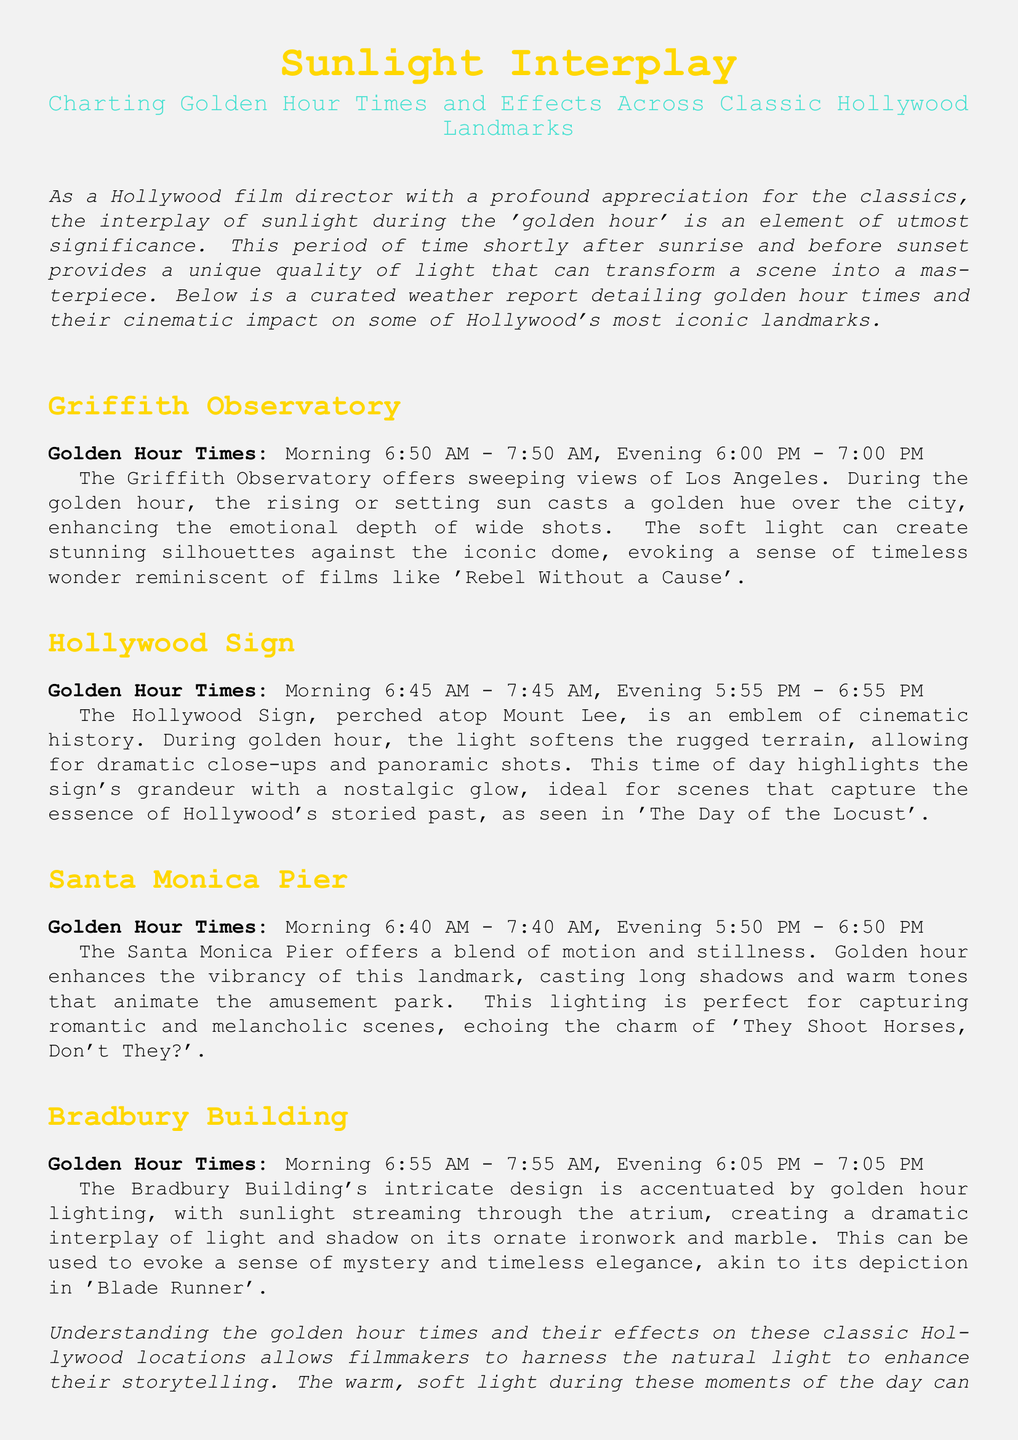What are the golden hour times for the Griffith Observatory? The golden hour times for the Griffith Observatory are provided in the document, showing specific morning and evening times.
Answer: Morning 6:50 AM - 7:50 AM, Evening 6:00 PM - 7:00 PM Which classic film is referenced in relation to the Griffith Observatory? The document mentions classic films that evoke the emotional depth of scenes filmed at the Griffith Observatory.
Answer: Rebel Without a Cause How does golden hour light affect the Hollywood Sign? The document explains how golden hour light impacts the appearance of the Hollywood Sign for cinematic purposes.
Answer: Softens the rugged terrain What are the evening golden hour times for the Bradbury Building? The document specifies the evening golden hour times unique to the Bradbury Building location.
Answer: 6:05 PM - 7:05 PM Which landmark's lighting is ideal for capturing scenes reminiscent of 'They Shoot Horses, Don't They?' The document relates certain landmarks to classic films, identifying one that stands out.
Answer: Santa Monica Pier What is the main emotion portrayed by golden hour lighting at the Santa Monica Pier? The document describes the types of scenes that can be enhanced by the lighting at this location.
Answer: Romantic and melancholic How does the representation of the Bradbury Building contribute to a sense of mystery? The document discusses the effects of golden hour lighting on the architecture of the Bradbury Building.
Answer: Dramatic interplay of light and shadow What is the historical significance of the Hollywood Sign as mentioned in the report? The document highlights the emblematic status of the Hollywood Sign within cinematic history.
Answer: Emblem of cinematic history 